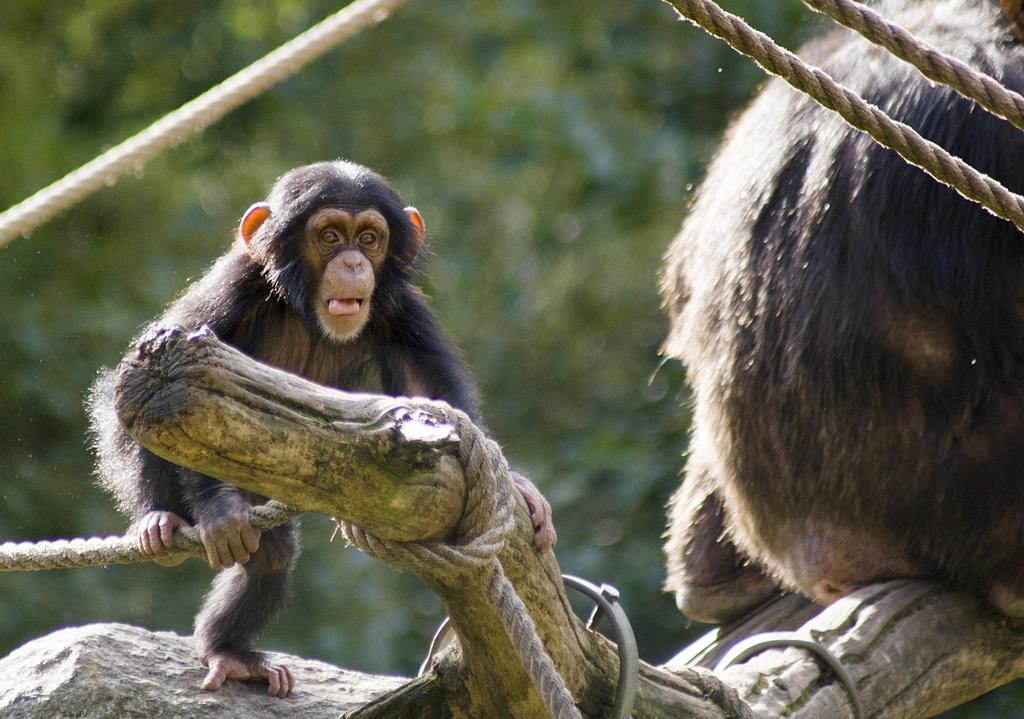What animals are present in the image? There are monkeys in the image. Where are the monkeys located? The monkeys are on a tree trunk in the image. What else can be seen in the image related to the tree trunk? There are ropes tied to the tree trunks in the image. What type of pizzas can be seen hanging from the tree trunk in the image? There are no pizzas present in the image; it features monkeys on a tree trunk with ropes tied to it. What material is the quiver made of that the monkeys are using to store their copper in the image? There is no quiver or copper present in the image; it only features monkeys on a tree trunk with ropes tied to it. 